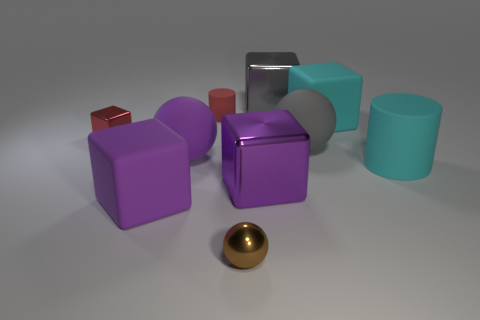Which objects in the image appear to have smooth surfaces? Most of the objects in the image possess smooth surfaces, notably the gold metal ball, the steel cube, and the geometric shapes with matte finishes such as the cylinders and cubes. 